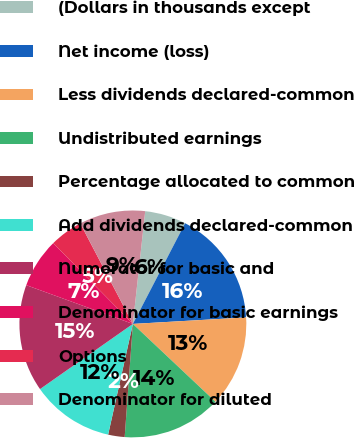<chart> <loc_0><loc_0><loc_500><loc_500><pie_chart><fcel>(Dollars in thousands except<fcel>Net income (loss)<fcel>Less dividends declared-common<fcel>Undistributed earnings<fcel>Percentage allocated to common<fcel>Add dividends declared-common<fcel>Numerator for basic and<fcel>Denominator for basic earnings<fcel>Options<fcel>Denominator for diluted<nl><fcel>5.88%<fcel>16.47%<fcel>12.94%<fcel>14.12%<fcel>2.35%<fcel>11.76%<fcel>15.29%<fcel>7.06%<fcel>4.71%<fcel>9.41%<nl></chart> 